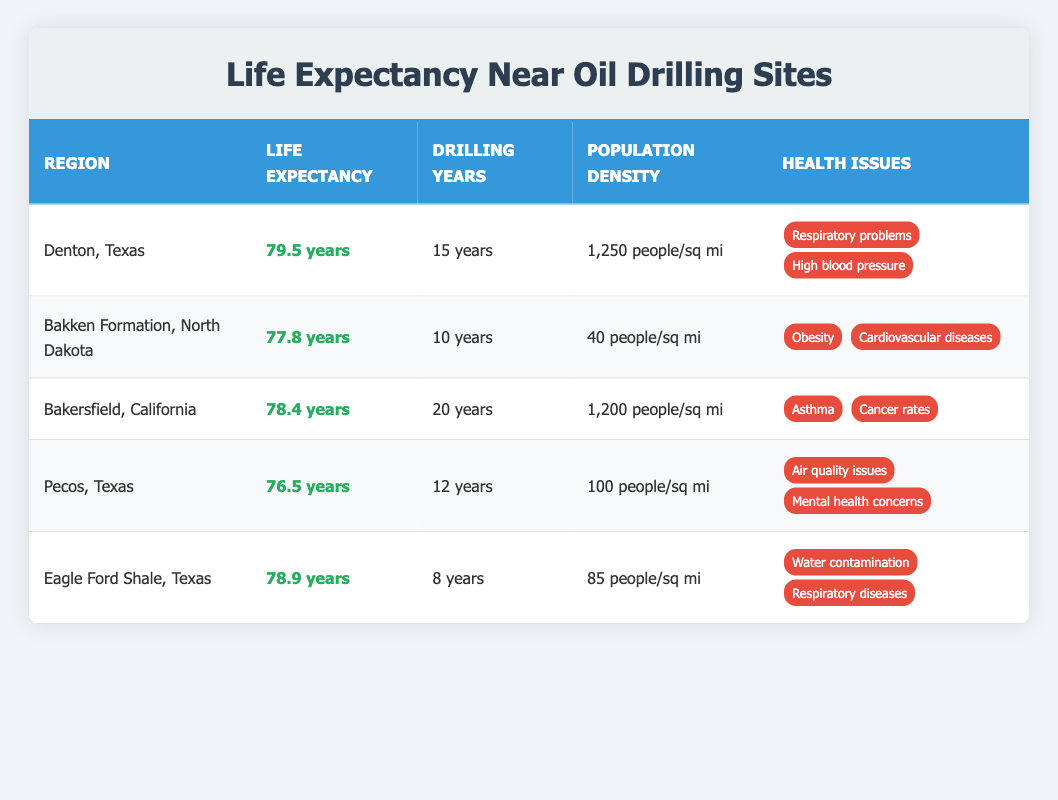What is the average life expectancy in Denton, Texas? The table shows that the average life expectancy in Denton, Texas is listed as 79.5 years. Therefore, the answer is directly obtained from the table.
Answer: 79.5 years Which region has the lowest life expectancy? By comparing the life expectancy values in the table, Pecos, Texas has the lowest value at 76.5 years. This value is less than those in all other regions listed.
Answer: Pecos, Texas What is the total number of years oil drilling has been active in all regions? To find the total, we sum the years of oil drilling from each region: 15 + 10 + 20 + 12 + 8 = 75. Therefore, the total number of active years is the sum of these numbers.
Answer: 75 years Is the average life expectancy higher in Bakersfield, California than in the Bakken Formation, North Dakota? The average life expectancy for Bakersfield, California is 78.4 years, while for the Bakken Formation, North Dakota it is 77.8 years. Since 78.4 is greater than 77.8, the statement is true.
Answer: Yes How many regions have average life expectancy below 79 years? The life expectancies below 79 years can be counted by examining the table: Bakken Formation (77.8), Bakersfield (78.4), Pecos (76.5), and Eagle Ford Shale (78.9). The regions with life expectancy below 79 years are four.
Answer: 4 regions If we average the life expectancy of all regions listed, what is the result? To find the average life expectancy: (79.5 + 77.8 + 78.4 + 76.5 + 78.9) / 5 = 78.42. The sum is 390.1, and when divided by the number of regions (5), we obtain approximately 78.42 years.
Answer: 78.42 years Do regions with a higher population density generally show higher life expectancy? Looking at the table, Denton (1,250) and Bakersfield (1,200) have high population densities and higher life expectancy, while Pecos (100) has low density and the lowest life expectancy. However, Eagle Ford Shale has a low density and a higher life expectancy, indicating no consistent correlation.
Answer: No Which notable health issue is common in both Denton, Texas and Eagle Ford Shale, Texas? By reviewing the notable health issues in the table, both regions list respiratory problems in their health concerns. This indicates a commonality in health issues related to oil drilling.
Answer: Respiratory problems 